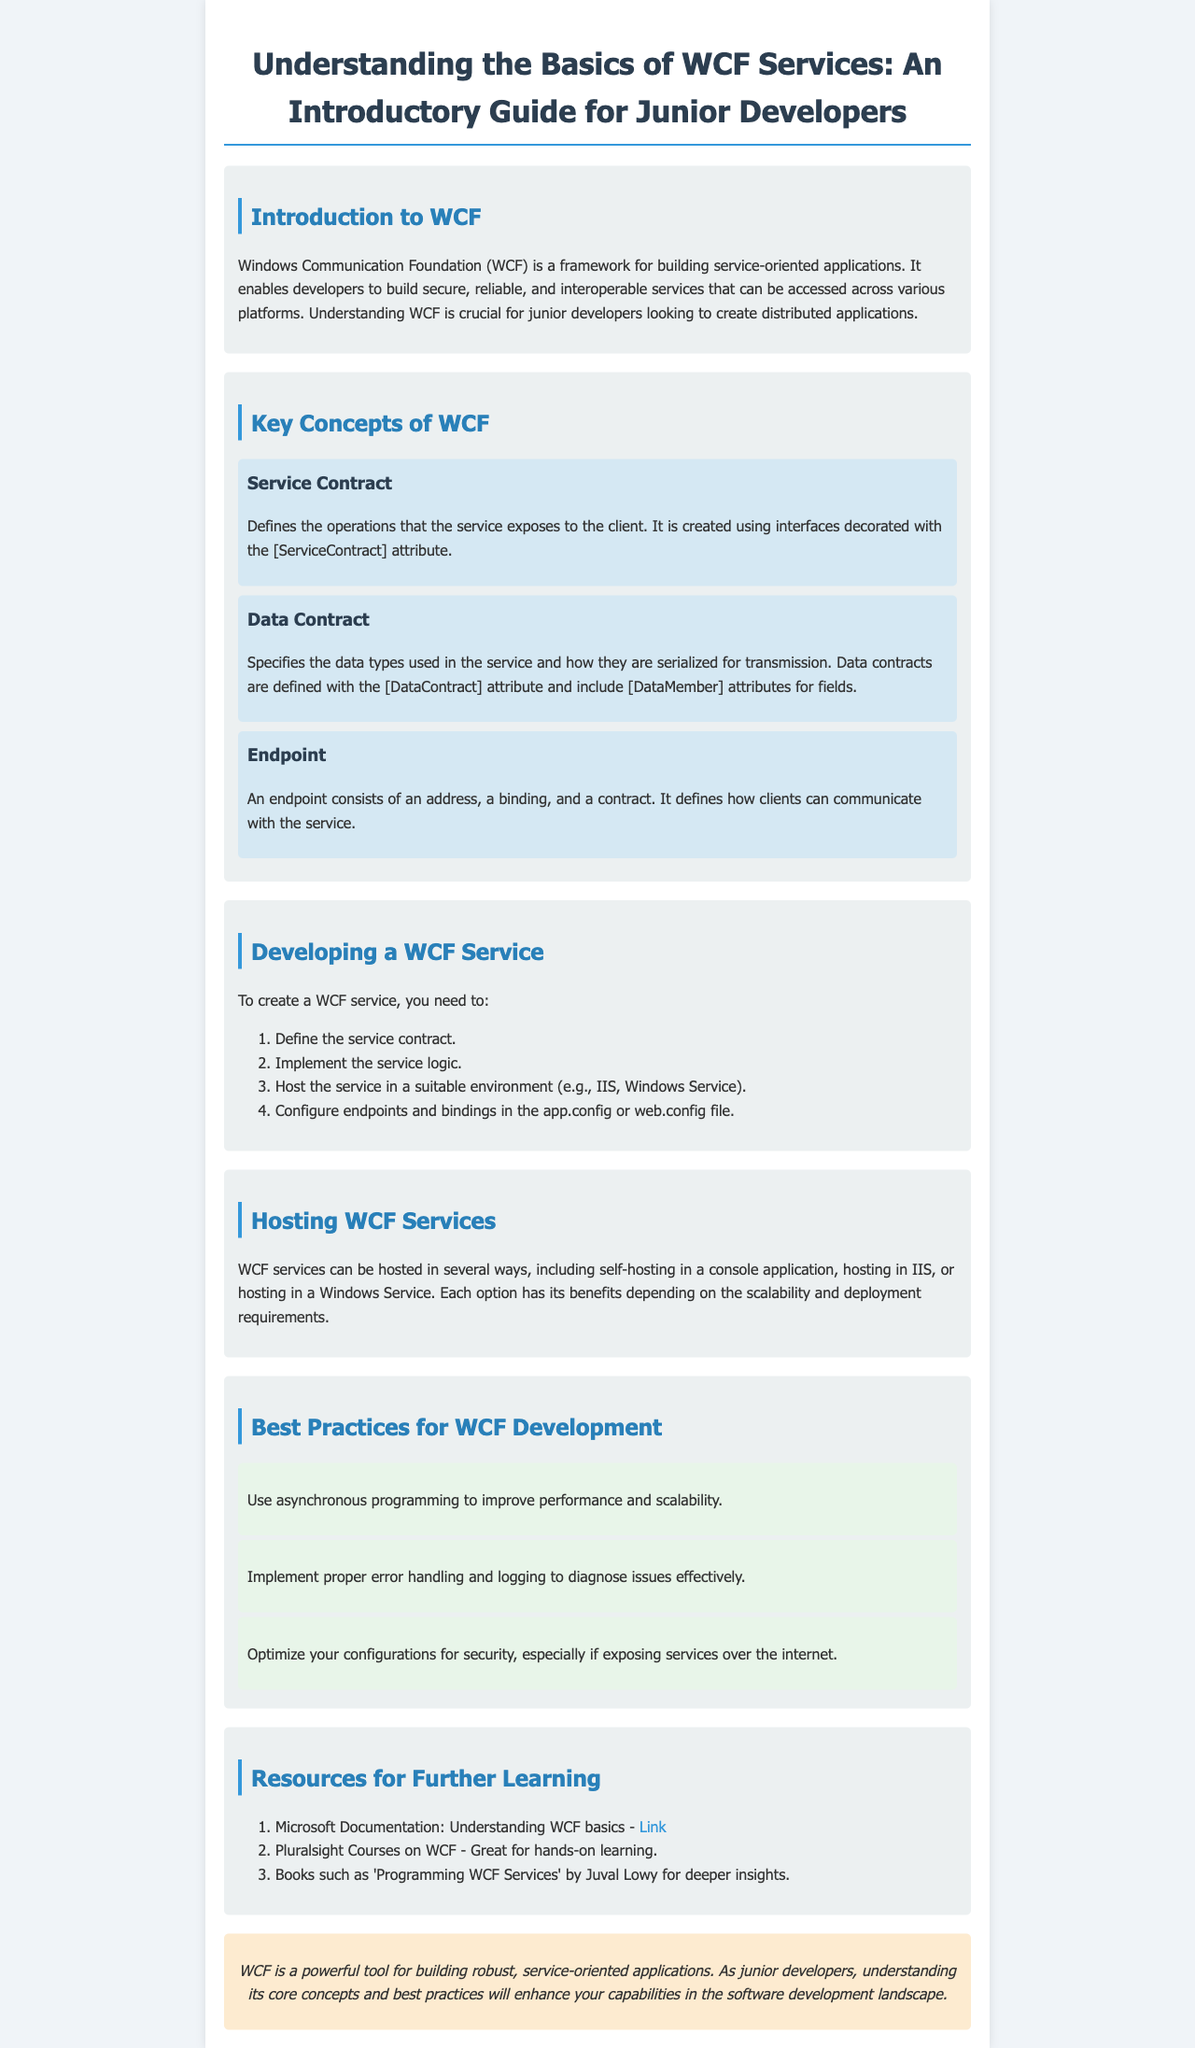What is WCF? WCF stands for Windows Communication Foundation, which is a framework for building service-oriented applications.
Answer: Windows Communication Foundation What attribute is used to define a service contract? The service contract is defined using interfaces decorated with a specific attribute.
Answer: ServiceContract What three components make up an endpoint? An endpoint is defined by three components as mentioned in the document.
Answer: Address, binding, contract How many steps are there to create a WCF service? The document outlines a specific number of steps needed to create a WCF service.
Answer: Four What type of hosting option is mentioned for WCF services? The document lists several hosting options for WCF services, highlighting a specific one.
Answer: IIS What should be used to improve performance and scalability in WCF development? The guide recommends a particular programming approach for enhancing performance and scalability.
Answer: Asynchronous programming What is a recommended resource for further learning about WCF? The document provides a link to a specific resource for additional learning about WCF.
Answer: Microsoft Documentation What is the purpose of a data contract? The data contract specifies a particular aspect of how data types are treated in the WCF service.
Answer: Serialization What color scheme is used for best practice sections in the document? The document uses a specific background color to differentiate best practice sections.
Answer: Light green 